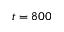<formula> <loc_0><loc_0><loc_500><loc_500>t = 8 0 0</formula> 